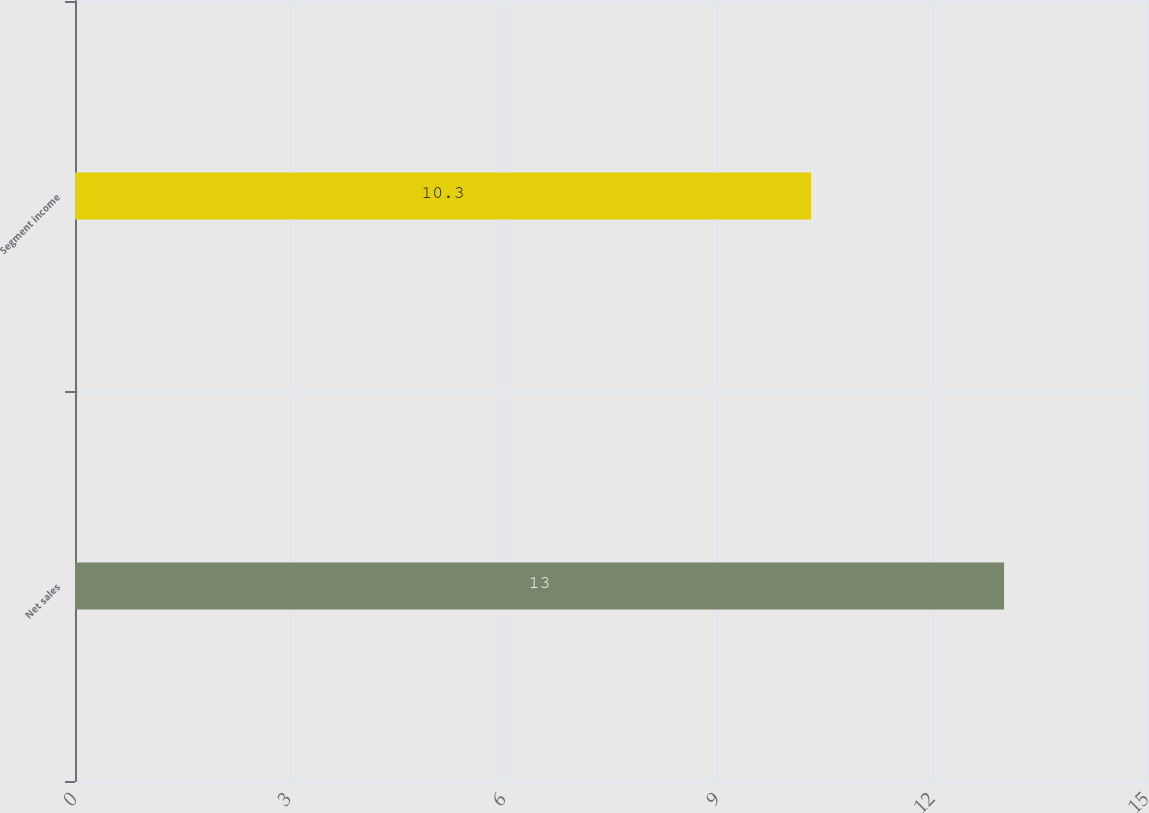<chart> <loc_0><loc_0><loc_500><loc_500><bar_chart><fcel>Net sales<fcel>Segment income<nl><fcel>13<fcel>10.3<nl></chart> 